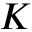Convert formula to latex. <formula><loc_0><loc_0><loc_500><loc_500>K</formula> 